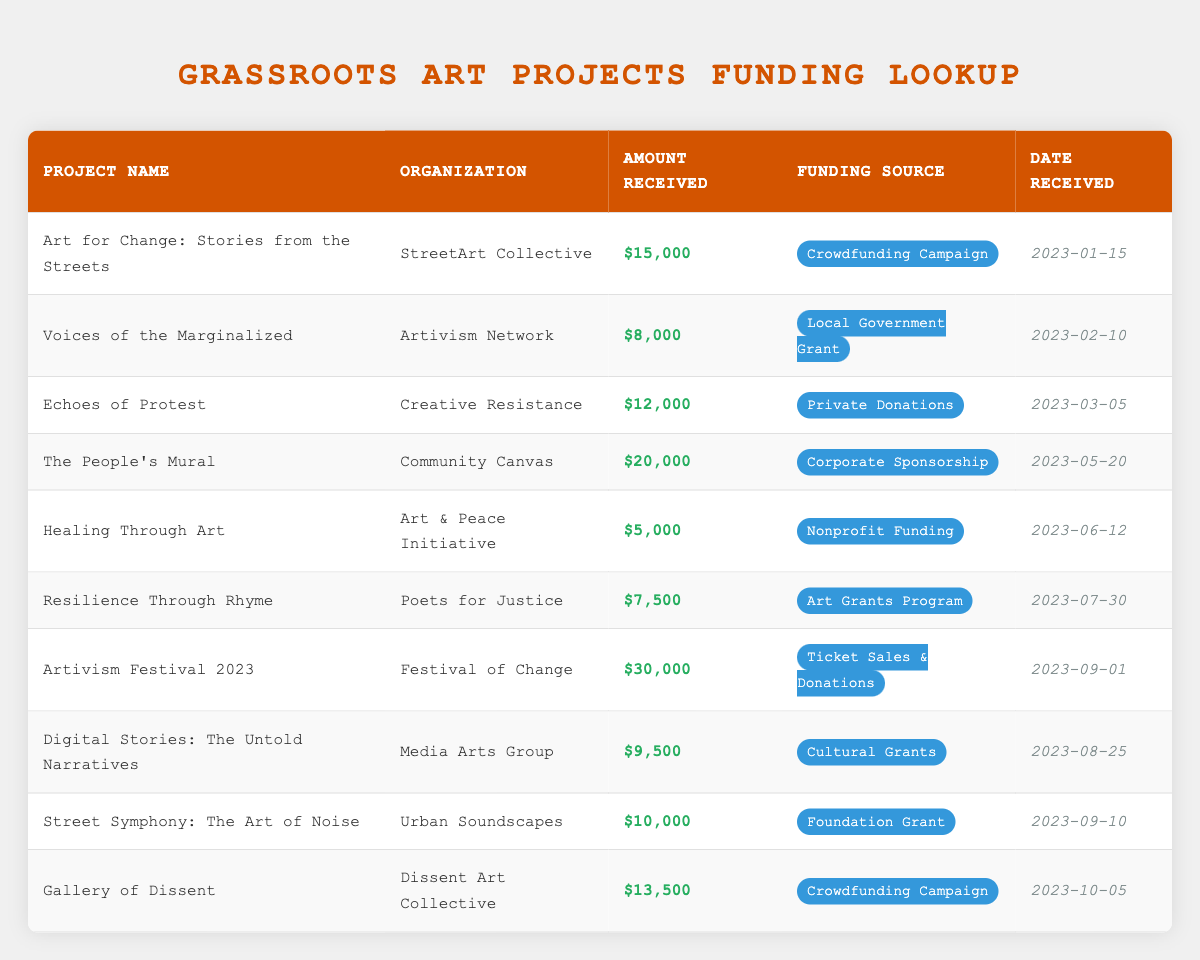What is the highest amount received for a grassroots art project? Looking at the "Amount Received" column, the highest value is associated with the project "Artivism Festival 2023," which received 30,000.
Answer: 30,000 How many projects received funding from Crowdfunding Campaigns? There are two projects that received funding from Crowdfunding Campaigns: "Art for Change: Stories from the Streets" and "Gallery of Dissent."
Answer: 2 What is the total amount received for projects funded by Corporate Sponsorship? The only project funded by Corporate Sponsorship is "The People's Mural," which received 20,000. Therefore, the total amount is just 20,000.
Answer: 20,000 Did any project receive less than 6,000? Checking the "Amount Received" column, only "Healing Through Art" received 5,000, which is less than 6,000. Therefore, the answer is yes.
Answer: Yes What is the average amount received by projects funded by Art Grants Program and Cultural Grants? The projects "Resilience Through Rhyme" (7,500) and "Digital Stories: The Untold Narratives" (9,500) received funding from these sources. First, sum these amounts: 7,500 + 9,500 = 17,000. Then, divide by the number of projects: 17,000 / 2 = 8,500.
Answer: 8,500 Which organization received the least funding, and what was the amount? Looking at the "Amount Received" values, "Healing Through Art" from "Art & Peace Initiative" received the least funding of 5,000.
Answer: Healing Through Art, 5,000 How many projects received funding after June 1, 2023? We look at the "Date Received" column. Projects after June 1, 2023, are "Artivism Festival 2023," "Digital Stories: The Untold Narratives," "Street Symphony: The Art of Noise," and "Gallery of Dissent." This counts to four projects.
Answer: 4 What is the difference in funding between the highest and lowest funded projects? The highest funded project is "Artivism Festival 2023" with 30,000, and the lowest is "Healing Through Art" with 5,000. Therefore, the difference is 30,000 - 5,000 = 25,000.
Answer: 25,000 Which funding source had the most projects associated with it, and how many projects were there? Both "Crowdfunding Campaign" and "Ticket Sales & Donations" had two projects each: "Art for Change: Stories from the Streets" and "Gallery of Dissent" for Crowdfunding, and "Artivism Festival 2023" for Ticket Sales & Donations. So, there are multiple sources with the same amount.
Answer: Crowdfunding Campaign, 2 